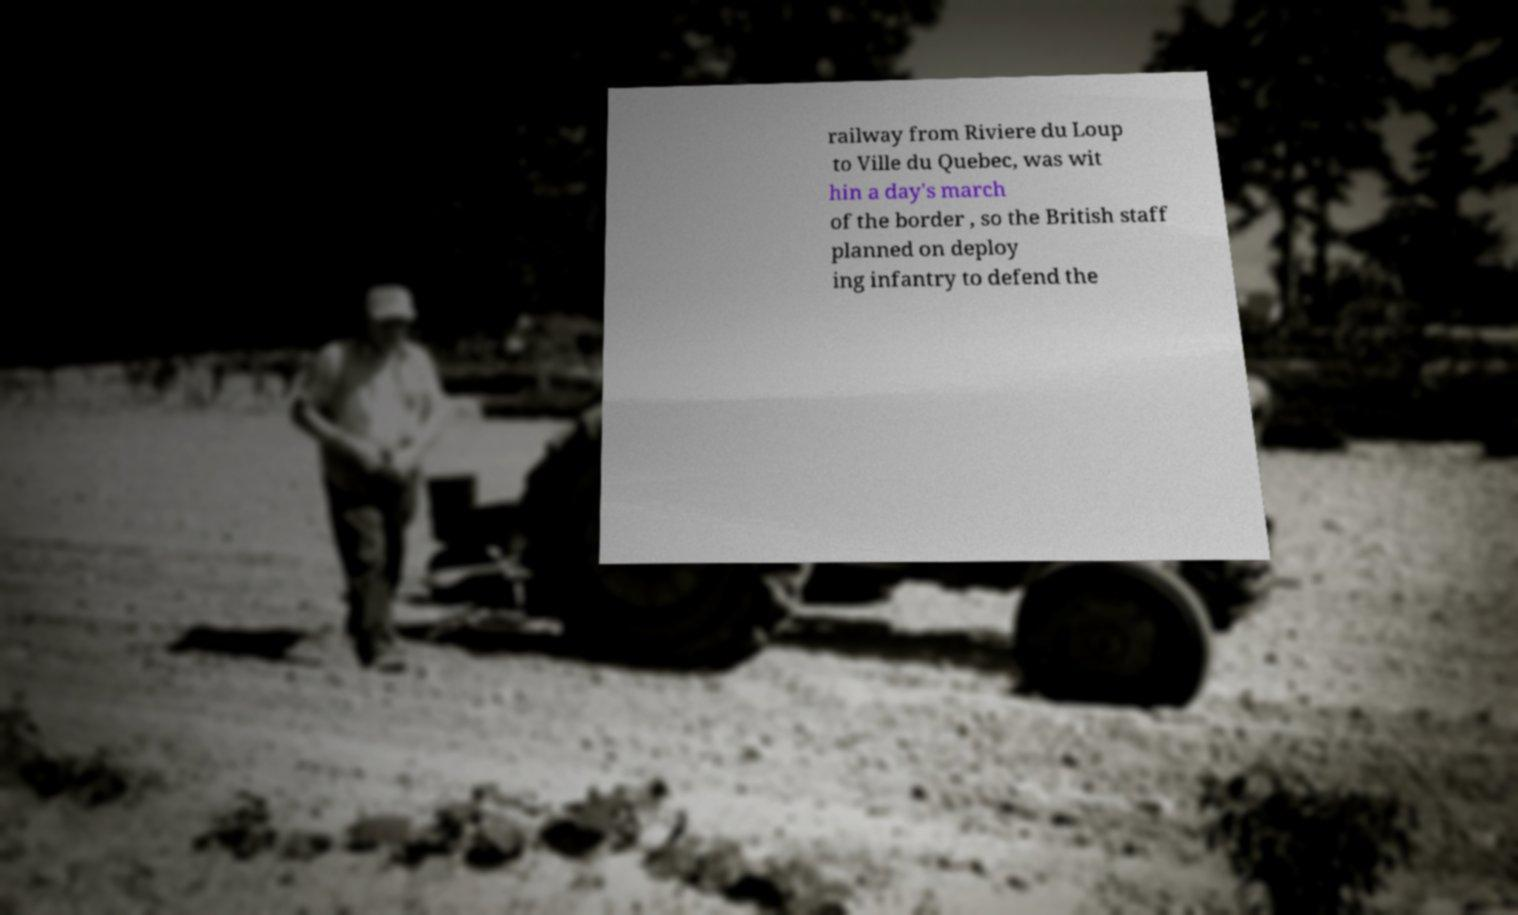Can you read and provide the text displayed in the image?This photo seems to have some interesting text. Can you extract and type it out for me? railway from Riviere du Loup to Ville du Quebec, was wit hin a day's march of the border , so the British staff planned on deploy ing infantry to defend the 